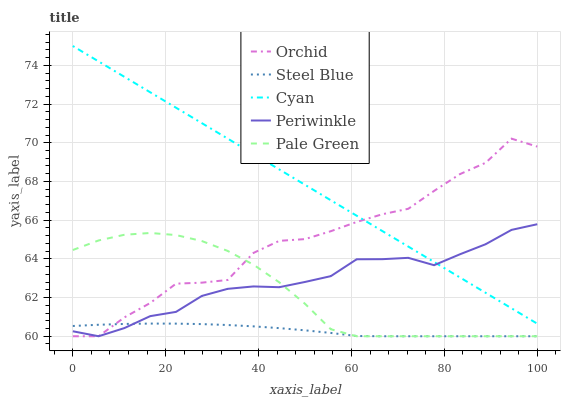Does Pale Green have the minimum area under the curve?
Answer yes or no. No. Does Pale Green have the maximum area under the curve?
Answer yes or no. No. Is Pale Green the smoothest?
Answer yes or no. No. Is Pale Green the roughest?
Answer yes or no. No. Does Pale Green have the highest value?
Answer yes or no. No. Is Steel Blue less than Cyan?
Answer yes or no. Yes. Is Cyan greater than Pale Green?
Answer yes or no. Yes. Does Steel Blue intersect Cyan?
Answer yes or no. No. 